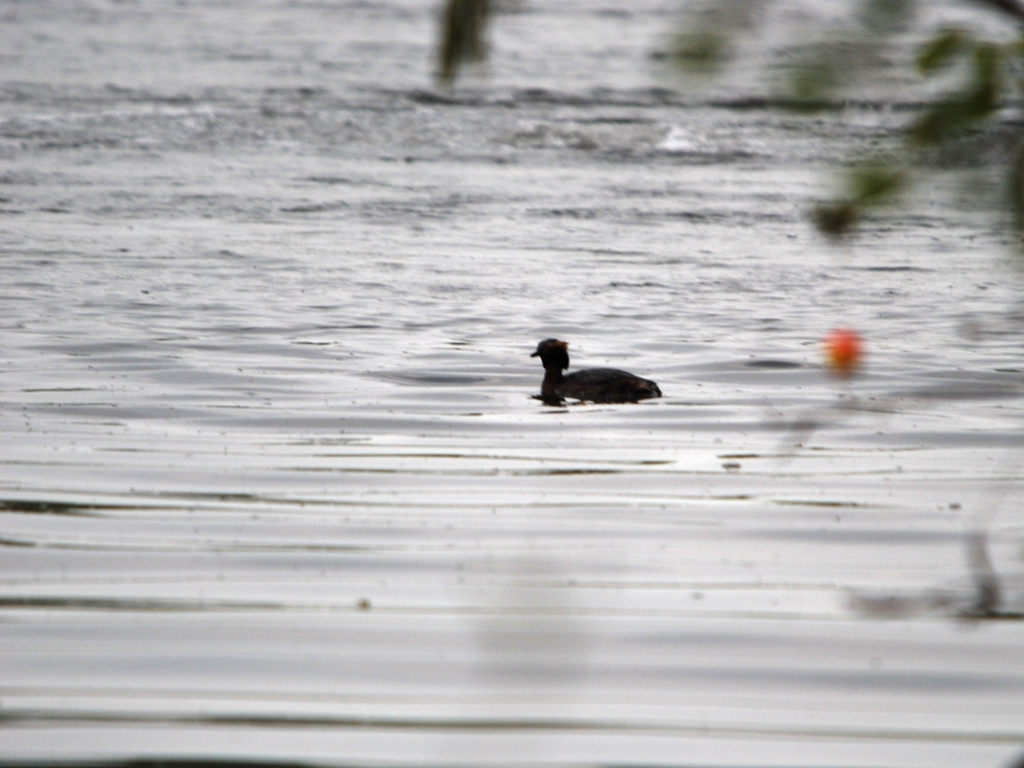What is the quality of this image?
A. Poor
B. Average
C. Good
D. Excellent The quality of this image would generally be considered as poor (Option A). This evaluation is based on the apparent lack of sharpness, considerable presence of motion blur, and the subject's lack of focus. The image also lacks proper exposure which hinders the detail and potential color accuracy of the scene. 